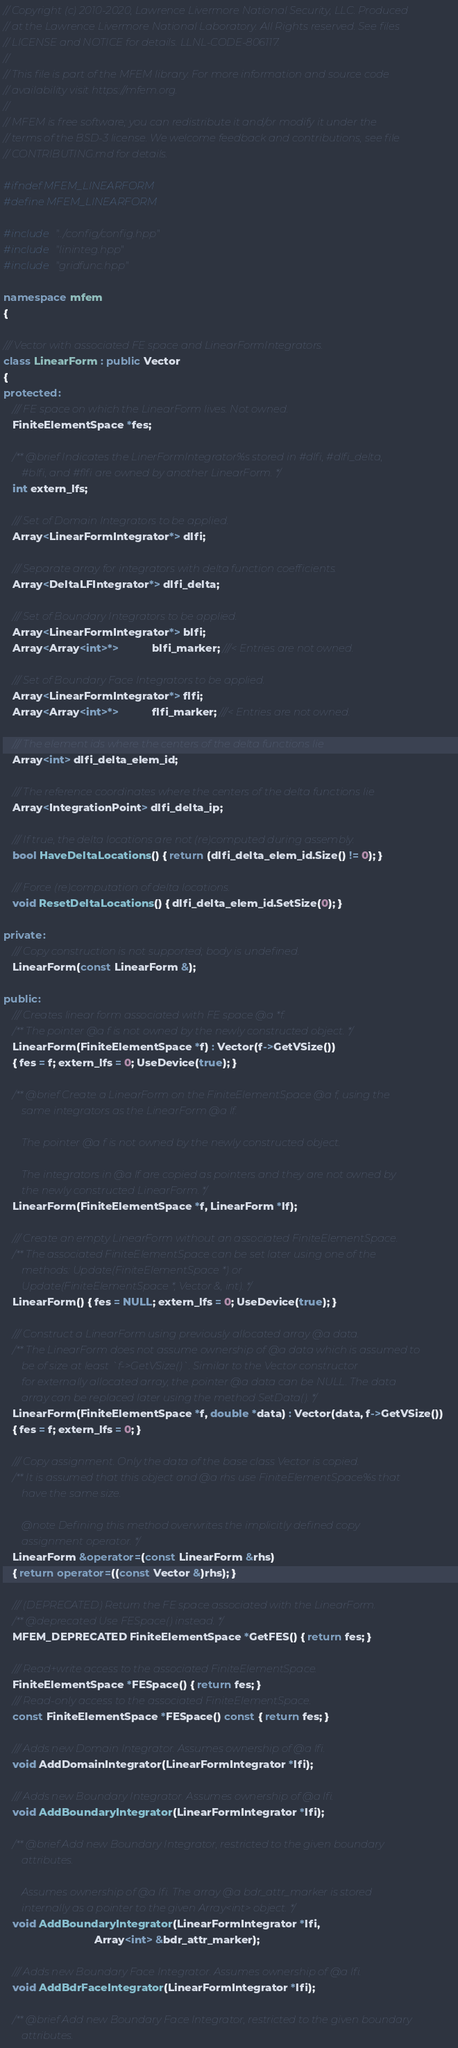Convert code to text. <code><loc_0><loc_0><loc_500><loc_500><_C++_>// Copyright (c) 2010-2020, Lawrence Livermore National Security, LLC. Produced
// at the Lawrence Livermore National Laboratory. All Rights reserved. See files
// LICENSE and NOTICE for details. LLNL-CODE-806117.
//
// This file is part of the MFEM library. For more information and source code
// availability visit https://mfem.org.
//
// MFEM is free software; you can redistribute it and/or modify it under the
// terms of the BSD-3 license. We welcome feedback and contributions, see file
// CONTRIBUTING.md for details.

#ifndef MFEM_LINEARFORM
#define MFEM_LINEARFORM

#include "../config/config.hpp"
#include "lininteg.hpp"
#include "gridfunc.hpp"

namespace mfem
{

/// Vector with associated FE space and LinearFormIntegrators.
class LinearForm : public Vector
{
protected:
   /// FE space on which the LinearForm lives. Not owned.
   FiniteElementSpace *fes;

   /** @brief Indicates the LinerFormIntegrator%s stored in #dlfi, #dlfi_delta,
       #blfi, and #flfi are owned by another LinearForm. */
   int extern_lfs;

   /// Set of Domain Integrators to be applied.
   Array<LinearFormIntegrator*> dlfi;

   /// Separate array for integrators with delta function coefficients.
   Array<DeltaLFIntegrator*> dlfi_delta;

   /// Set of Boundary Integrators to be applied.
   Array<LinearFormIntegrator*> blfi;
   Array<Array<int>*>           blfi_marker; ///< Entries are not owned.

   /// Set of Boundary Face Integrators to be applied.
   Array<LinearFormIntegrator*> flfi;
   Array<Array<int>*>           flfi_marker; ///< Entries are not owned.

   /// The element ids where the centers of the delta functions lie
   Array<int> dlfi_delta_elem_id;

   /// The reference coordinates where the centers of the delta functions lie
   Array<IntegrationPoint> dlfi_delta_ip;

   /// If true, the delta locations are not (re)computed during assembly.
   bool HaveDeltaLocations() { return (dlfi_delta_elem_id.Size() != 0); }

   /// Force (re)computation of delta locations.
   void ResetDeltaLocations() { dlfi_delta_elem_id.SetSize(0); }

private:
   /// Copy construction is not supported; body is undefined.
   LinearForm(const LinearForm &);

public:
   /// Creates linear form associated with FE space @a *f.
   /** The pointer @a f is not owned by the newly constructed object. */
   LinearForm(FiniteElementSpace *f) : Vector(f->GetVSize())
   { fes = f; extern_lfs = 0; UseDevice(true); }

   /** @brief Create a LinearForm on the FiniteElementSpace @a f, using the
       same integrators as the LinearForm @a lf.

       The pointer @a f is not owned by the newly constructed object.

       The integrators in @a lf are copied as pointers and they are not owned by
       the newly constructed LinearForm. */
   LinearForm(FiniteElementSpace *f, LinearForm *lf);

   /// Create an empty LinearForm without an associated FiniteElementSpace.
   /** The associated FiniteElementSpace can be set later using one of the
       methods: Update(FiniteElementSpace *) or
       Update(FiniteElementSpace *, Vector &, int). */
   LinearForm() { fes = NULL; extern_lfs = 0; UseDevice(true); }

   /// Construct a LinearForm using previously allocated array @a data.
   /** The LinearForm does not assume ownership of @a data which is assumed to
       be of size at least `f->GetVSize()`. Similar to the Vector constructor
       for externally allocated array, the pointer @a data can be NULL. The data
       array can be replaced later using the method SetData(). */
   LinearForm(FiniteElementSpace *f, double *data) : Vector(data, f->GetVSize())
   { fes = f; extern_lfs = 0; }

   /// Copy assignment. Only the data of the base class Vector is copied.
   /** It is assumed that this object and @a rhs use FiniteElementSpace%s that
       have the same size.

       @note Defining this method overwrites the implicitly defined copy
       assignment operator. */
   LinearForm &operator=(const LinearForm &rhs)
   { return operator=((const Vector &)rhs); }

   /// (DEPRECATED) Return the FE space associated with the LinearForm.
   /** @deprecated Use FESpace() instead. */
   MFEM_DEPRECATED FiniteElementSpace *GetFES() { return fes; }

   /// Read+write access to the associated FiniteElementSpace.
   FiniteElementSpace *FESpace() { return fes; }
   /// Read-only access to the associated FiniteElementSpace.
   const FiniteElementSpace *FESpace() const { return fes; }

   /// Adds new Domain Integrator. Assumes ownership of @a lfi.
   void AddDomainIntegrator(LinearFormIntegrator *lfi);

   /// Adds new Boundary Integrator. Assumes ownership of @a lfi.
   void AddBoundaryIntegrator(LinearFormIntegrator *lfi);

   /** @brief Add new Boundary Integrator, restricted to the given boundary
       attributes.

       Assumes ownership of @a lfi. The array @a bdr_attr_marker is stored
       internally as a pointer to the given Array<int> object. */
   void AddBoundaryIntegrator(LinearFormIntegrator *lfi,
                              Array<int> &bdr_attr_marker);

   /// Adds new Boundary Face Integrator. Assumes ownership of @a lfi.
   void AddBdrFaceIntegrator(LinearFormIntegrator *lfi);

   /** @brief Add new Boundary Face Integrator, restricted to the given boundary
       attributes.
</code> 